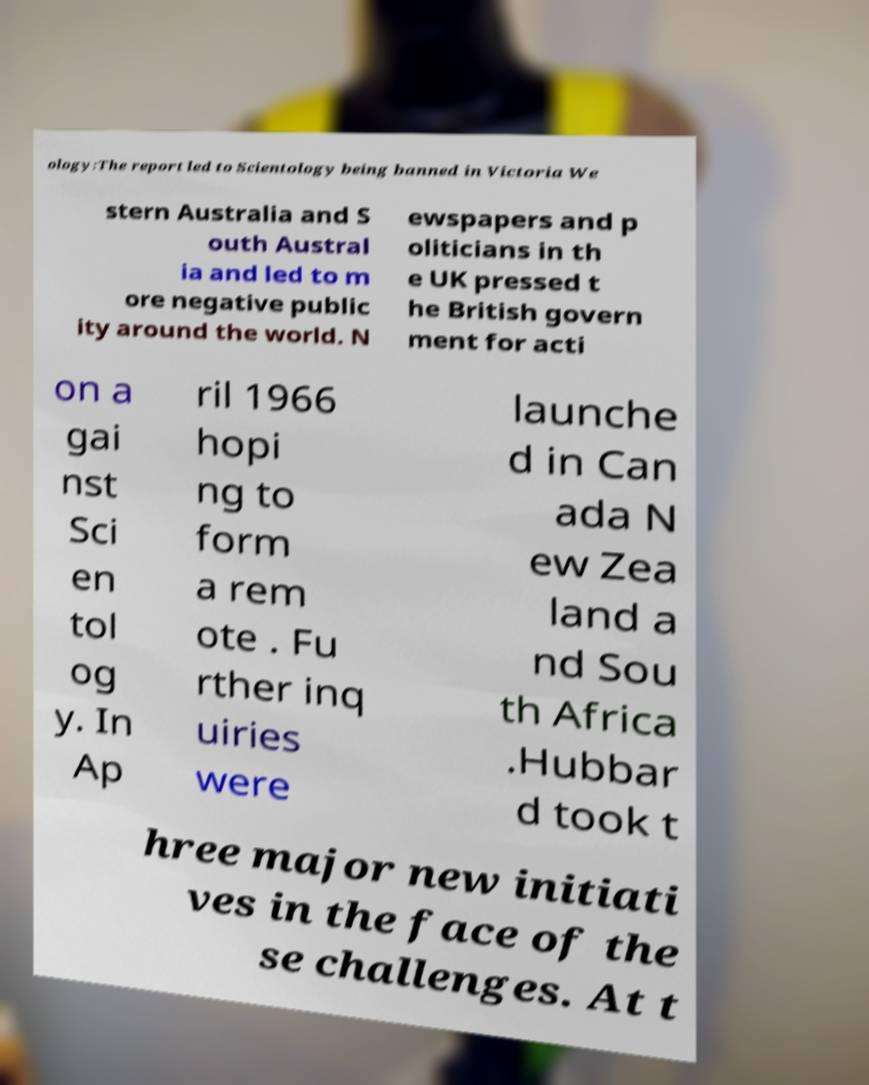What messages or text are displayed in this image? I need them in a readable, typed format. ology:The report led to Scientology being banned in Victoria We stern Australia and S outh Austral ia and led to m ore negative public ity around the world. N ewspapers and p oliticians in th e UK pressed t he British govern ment for acti on a gai nst Sci en tol og y. In Ap ril 1966 hopi ng to form a rem ote . Fu rther inq uiries were launche d in Can ada N ew Zea land a nd Sou th Africa .Hubbar d took t hree major new initiati ves in the face of the se challenges. At t 